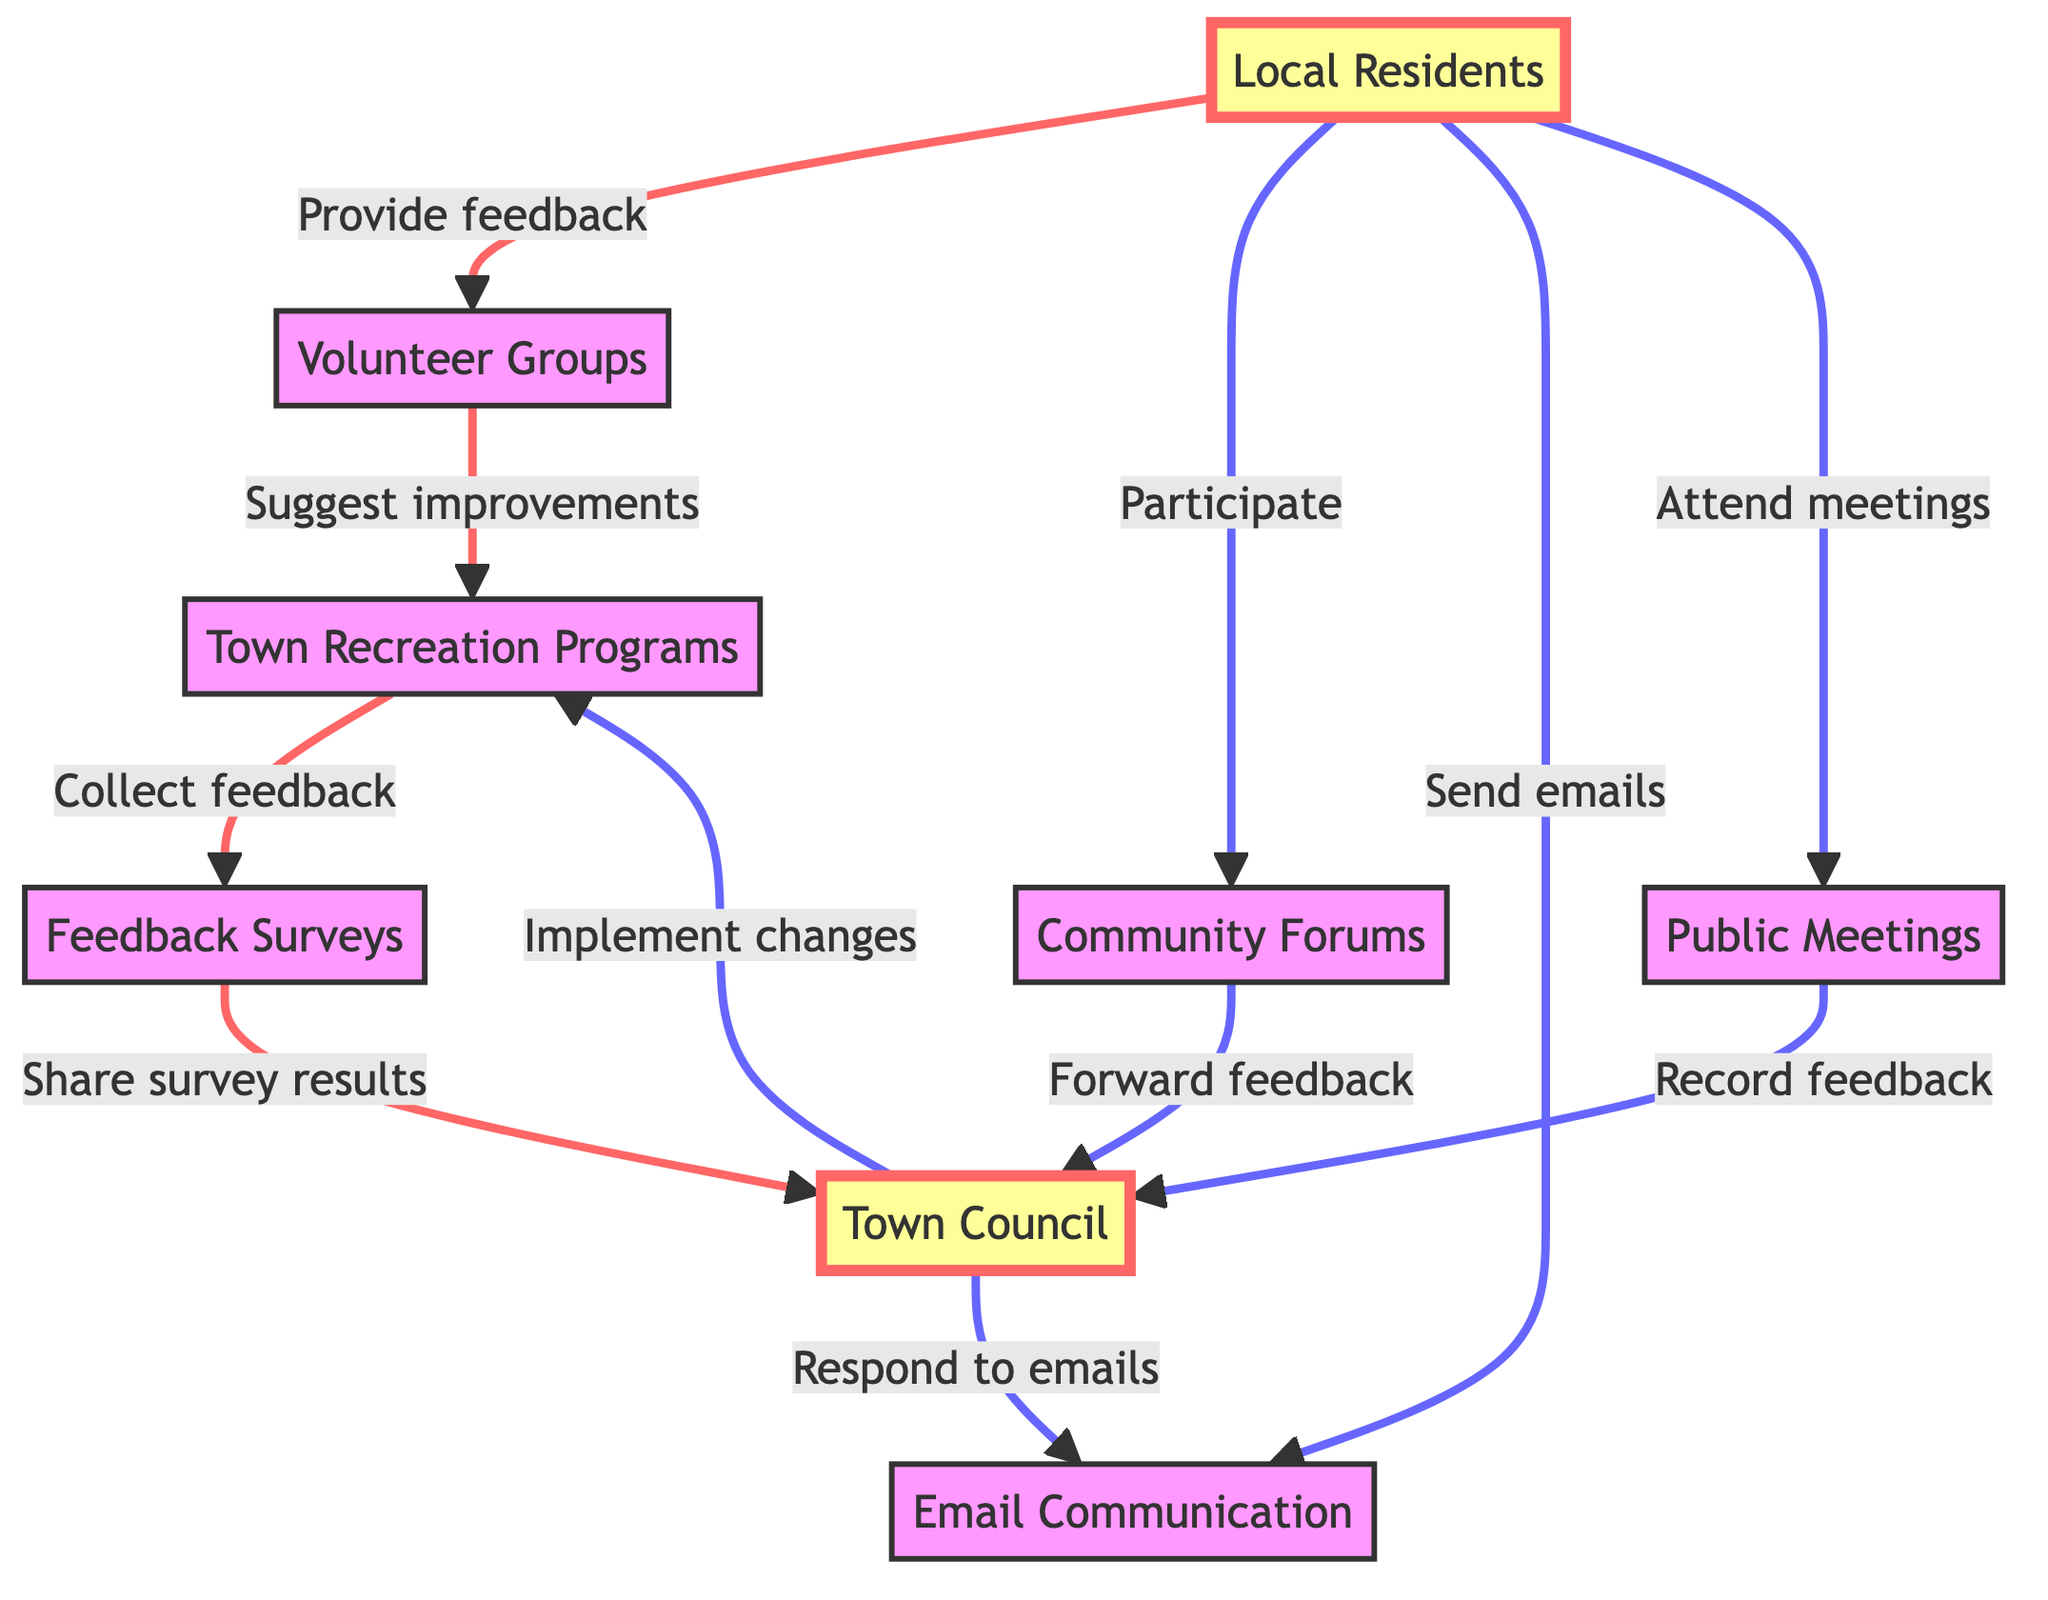What is the first node in the directed graph? The first node listed in the diagram is "Local Residents", which serves as the starting point of feedback flow in the communication process.
Answer: Local Residents How many edges are in this diagram? By counting the connections (edges) shown between the nodes, there are a total of 11 edges in the diagram.
Answer: 11 What do Volunteer Groups suggest to Town Recreation Programs? According to the directed connection from Volunteer Groups to Town Recreation Programs, they suggest improvements.
Answer: Suggest improvements How is feedback collected from Town Recreation Programs? The Town Recreation Programs collect feedback through feedback surveys, as indicated by the direct connection from Town Recreation Programs to Feedback Surveys.
Answer: Collect feedback What does the Town Council do after receiving survey results? Following the reception of survey results from Feedback Surveys, the Town Council shares these results, which is indicated by the connection from Feedback Surveys to Town Council.
Answer: Share survey results How many nodes represent communication methods in the diagram? The communication methods represented by nodes in the diagram include Email Communication, Community Forums, and Public Meetings. Therefore, there are three nodes representing communication methods.
Answer: 3 What do Local Residents do before attending Public Meetings? Local Residents send emails for feedback prior to attending Public Meetings, as evident from the connections in the diagram. This indicates a sequential involvement in the feedback process.
Answer: Send emails Which node directly implements changes to Town Recreation Programs? The Town Council directly implements changes, as indicated by the edge flowing from Town Council to Town Recreation Programs.
Answer: Town Council What is done with the feedback collected from the Community Forums? The feedback collected from Community Forums is forwarded to the Town Council, as shown by the directed edge connecting Community Forums to Town Council.
Answer: Forward feedback Which two nodes are connected by the "Respond to emails" relationship? The relationship "Respond to emails" connects the node Town Council to the node Email Communication, demonstrating the interaction between these two components.
Answer: Town Council and Email Communication 